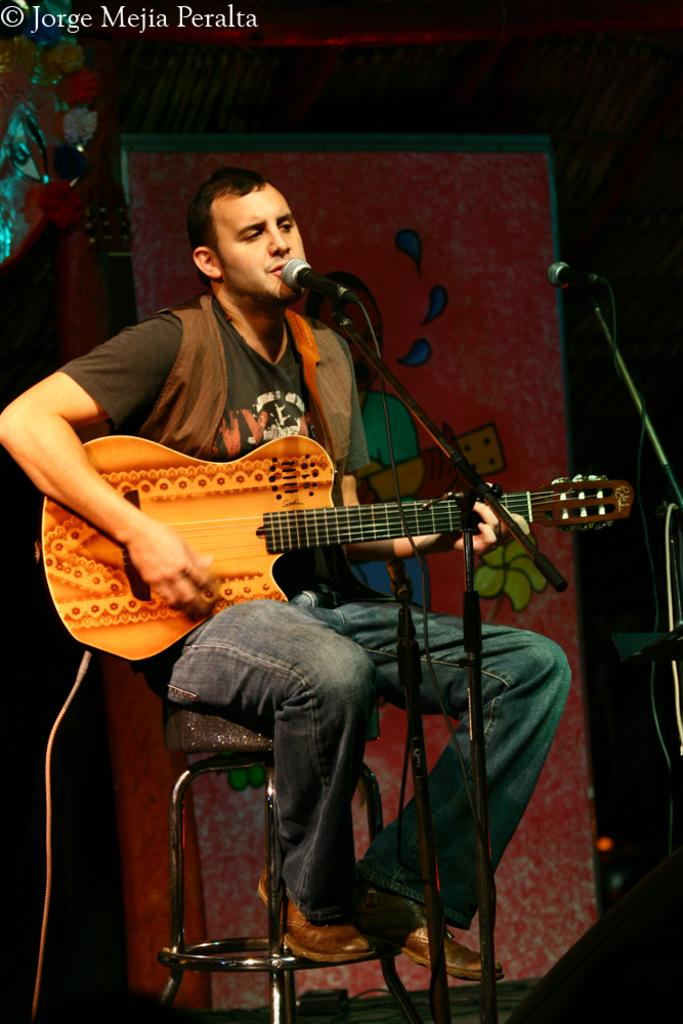Who or what is the main subject in the image? There is a person in the image. What is the person doing in the image? The person is sitting on a table and playing a guitar. What object is in front of the person? There is a microphone in front of the person. How many mice are crawling on the person's suit in the image? There is no suit or mice present in the image. 